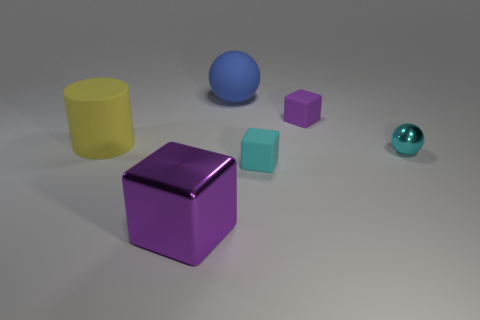How many other things are there of the same color as the cylinder?
Provide a succinct answer. 0. Are the large blue ball and the small purple thing made of the same material?
Ensure brevity in your answer.  Yes. There is a purple metal thing; what shape is it?
Your answer should be compact. Cube. There is a small block that is in front of the small matte thing behind the cyan shiny object; what number of purple metal things are in front of it?
Offer a very short reply. 1. There is a big shiny object that is the same shape as the small purple rubber thing; what color is it?
Provide a short and direct response. Purple. What shape is the metallic thing to the right of the big rubber thing that is to the right of the metallic thing left of the small cyan rubber block?
Keep it short and to the point. Sphere. There is a block that is right of the large purple metallic object and in front of the large rubber cylinder; what is its size?
Offer a very short reply. Small. Are there fewer big purple cubes than small brown metal blocks?
Make the answer very short. No. There is a metallic object on the left side of the small cyan cube; what size is it?
Offer a very short reply. Large. What shape is the thing that is in front of the yellow rubber cylinder and left of the tiny cyan rubber cube?
Your response must be concise. Cube. 